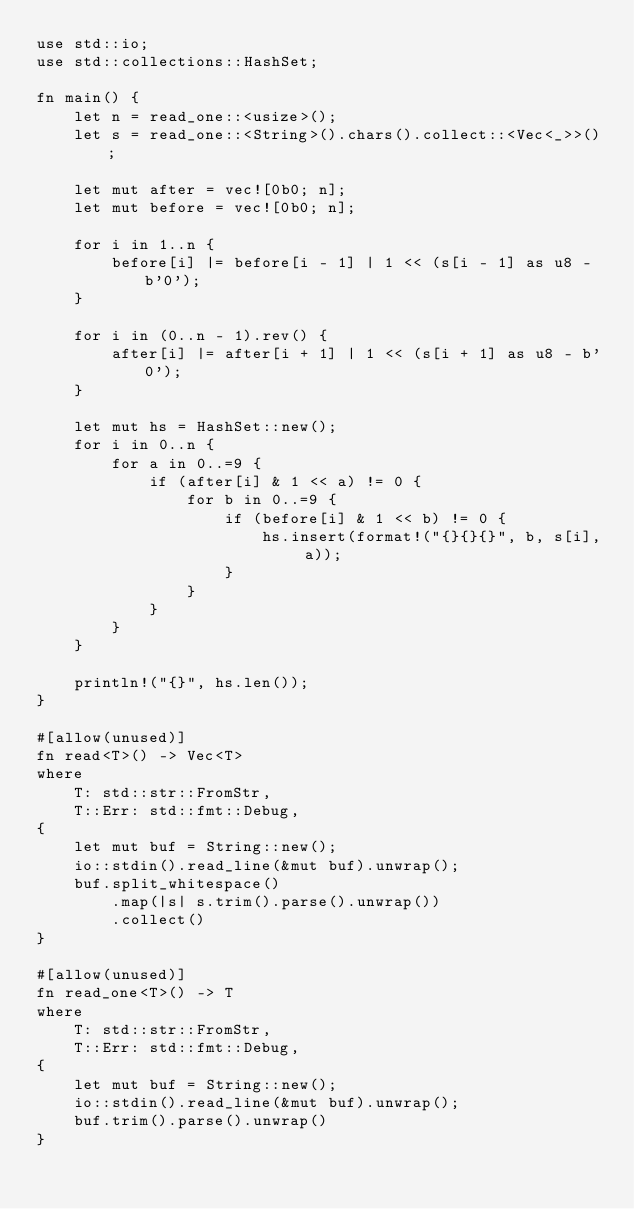Convert code to text. <code><loc_0><loc_0><loc_500><loc_500><_Rust_>use std::io;
use std::collections::HashSet;

fn main() {
    let n = read_one::<usize>();
    let s = read_one::<String>().chars().collect::<Vec<_>>();

    let mut after = vec![0b0; n];
    let mut before = vec![0b0; n];

    for i in 1..n {
        before[i] |= before[i - 1] | 1 << (s[i - 1] as u8 - b'0');
    }

    for i in (0..n - 1).rev() {
        after[i] |= after[i + 1] | 1 << (s[i + 1] as u8 - b'0');
    }

    let mut hs = HashSet::new();
    for i in 0..n {
        for a in 0..=9 {
            if (after[i] & 1 << a) != 0 {
                for b in 0..=9 {
                    if (before[i] & 1 << b) != 0 {
                        hs.insert(format!("{}{}{}", b, s[i], a));
                    }
                }
            }
        }
    }

    println!("{}", hs.len());
}

#[allow(unused)]
fn read<T>() -> Vec<T>
where
    T: std::str::FromStr,
    T::Err: std::fmt::Debug,
{
    let mut buf = String::new();
    io::stdin().read_line(&mut buf).unwrap();
    buf.split_whitespace()
        .map(|s| s.trim().parse().unwrap())
        .collect()
}

#[allow(unused)]
fn read_one<T>() -> T
where
    T: std::str::FromStr,
    T::Err: std::fmt::Debug,
{
    let mut buf = String::new();
    io::stdin().read_line(&mut buf).unwrap();
    buf.trim().parse().unwrap()
}</code> 